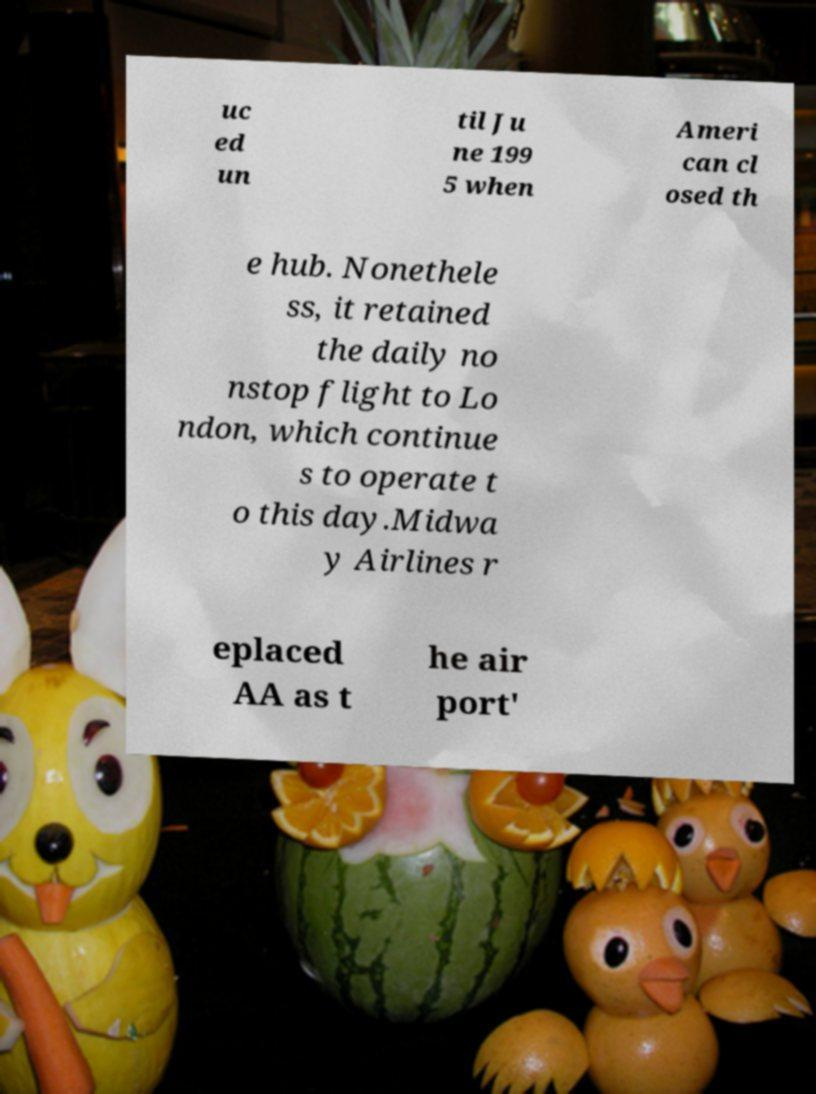Could you extract and type out the text from this image? uc ed un til Ju ne 199 5 when Ameri can cl osed th e hub. Nonethele ss, it retained the daily no nstop flight to Lo ndon, which continue s to operate t o this day.Midwa y Airlines r eplaced AA as t he air port' 